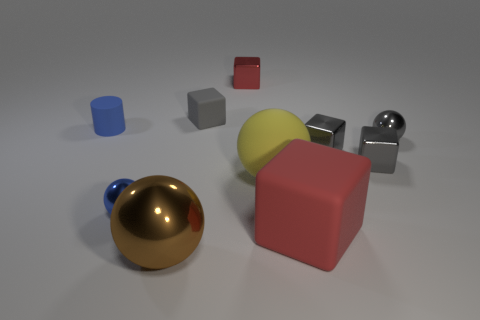How many objects in this scene are reflecting light? Multiple objects are reflecting light to varying degrees. The spheres and the metallic cube in particular show strong reflections, suggesting they have highly reflective surfaces. Counting them, at least three objects show pronounced reflections. 